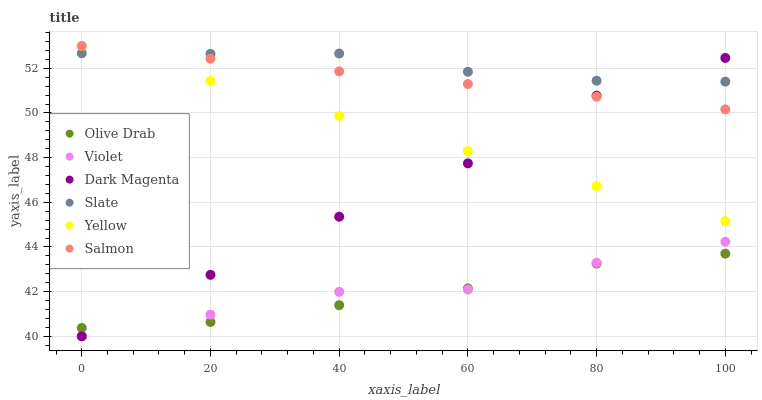Does Olive Drab have the minimum area under the curve?
Answer yes or no. Yes. Does Slate have the maximum area under the curve?
Answer yes or no. Yes. Does Salmon have the minimum area under the curve?
Answer yes or no. No. Does Salmon have the maximum area under the curve?
Answer yes or no. No. Is Yellow the smoothest?
Answer yes or no. Yes. Is Dark Magenta the roughest?
Answer yes or no. Yes. Is Slate the smoothest?
Answer yes or no. No. Is Slate the roughest?
Answer yes or no. No. Does Dark Magenta have the lowest value?
Answer yes or no. Yes. Does Salmon have the lowest value?
Answer yes or no. No. Does Yellow have the highest value?
Answer yes or no. Yes. Does Slate have the highest value?
Answer yes or no. No. Is Violet less than Yellow?
Answer yes or no. Yes. Is Salmon greater than Violet?
Answer yes or no. Yes. Does Yellow intersect Salmon?
Answer yes or no. Yes. Is Yellow less than Salmon?
Answer yes or no. No. Is Yellow greater than Salmon?
Answer yes or no. No. Does Violet intersect Yellow?
Answer yes or no. No. 